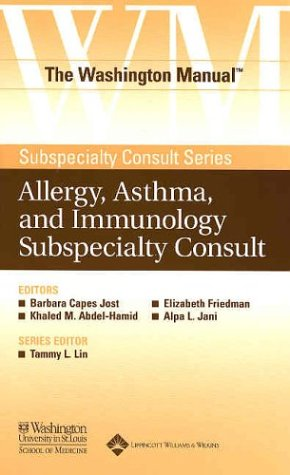Who is the author of this book? The authors identified on the cover are listed under the 'Washington University School of Medicine Department of Medicine', which includes several noted medical professionals contributing to this detailed consulation manual. 